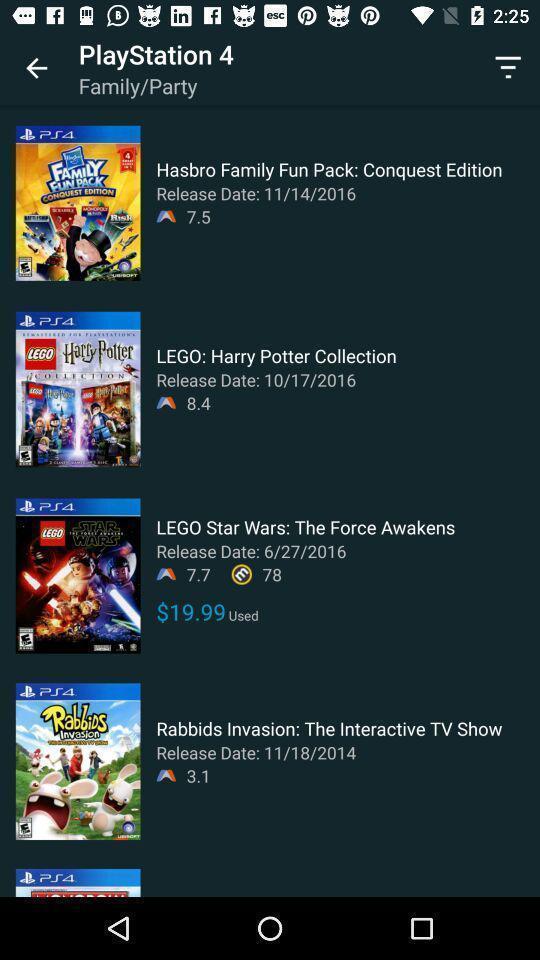Please provide a description for this image. Page showing multiple gaming apps. 